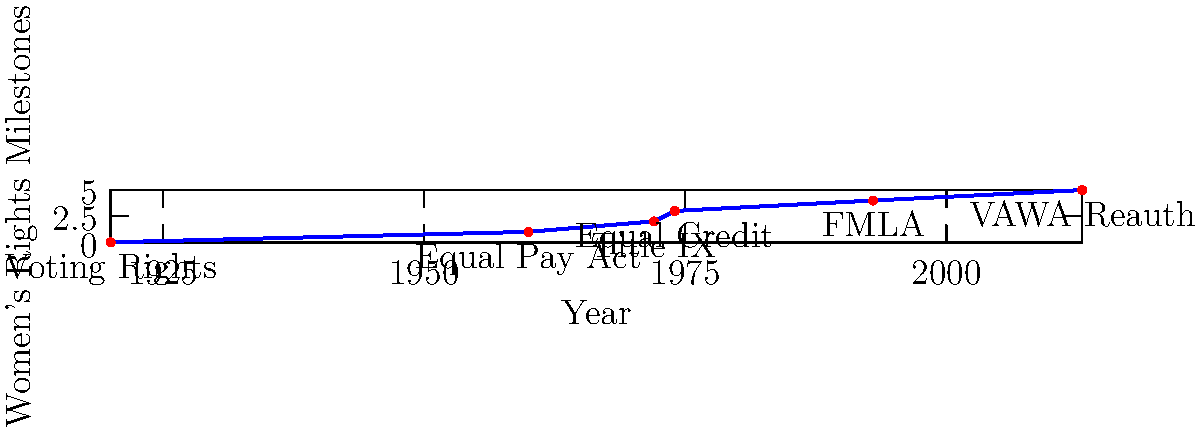Analyze the timeline infographic depicting major women's rights milestones in the United States. Which period showed the most rapid progression in terms of policy changes, and what factors might have contributed to this acceleration? To answer this question, we need to examine the timeline and identify the period with the steepest increase in women's rights milestones. Let's break it down step-by-step:

1. Observe the overall trend: The graph shows an upward trend from 1920 to 2013, indicating a general improvement in women's rights over time.

2. Identify distinct periods:
   a. 1920-1960: 40-year gap, 1 milestone
   b. 1960-1974: 14-year period, 3 milestones
   c. 1974-1993: 19-year gap, 1 milestone
   d. 1993-2013: 20-year gap, 1 milestone

3. Calculate the rate of change for each period:
   a. 1920-1960: 1 milestone / 40 years = 0.025 milestones/year
   b. 1960-1974: 3 milestones / 14 years ≈ 0.214 milestones/year
   c. 1974-1993: 1 milestone / 19 years ≈ 0.053 milestones/year
   d. 1993-2013: 1 milestone / 20 years = 0.05 milestones/year

4. Identify the period with the highest rate: 1960-1974

5. Factors contributing to this acceleration:
   a. Civil Rights Movement: Increased awareness of social inequalities
   b. Second-wave feminism: Focused on workplace, legal, and social equality
   c. Political climate: Growing support for social reform
   d. Economic changes: More women entering the workforce

The period from 1960 to 1974 showed the most rapid progression in women's rights policy changes, likely due to the convergence of social movements, political will, and economic shifts during this era.
Answer: 1960-1974; influenced by Civil Rights Movement, second-wave feminism, political climate, and economic changes. 